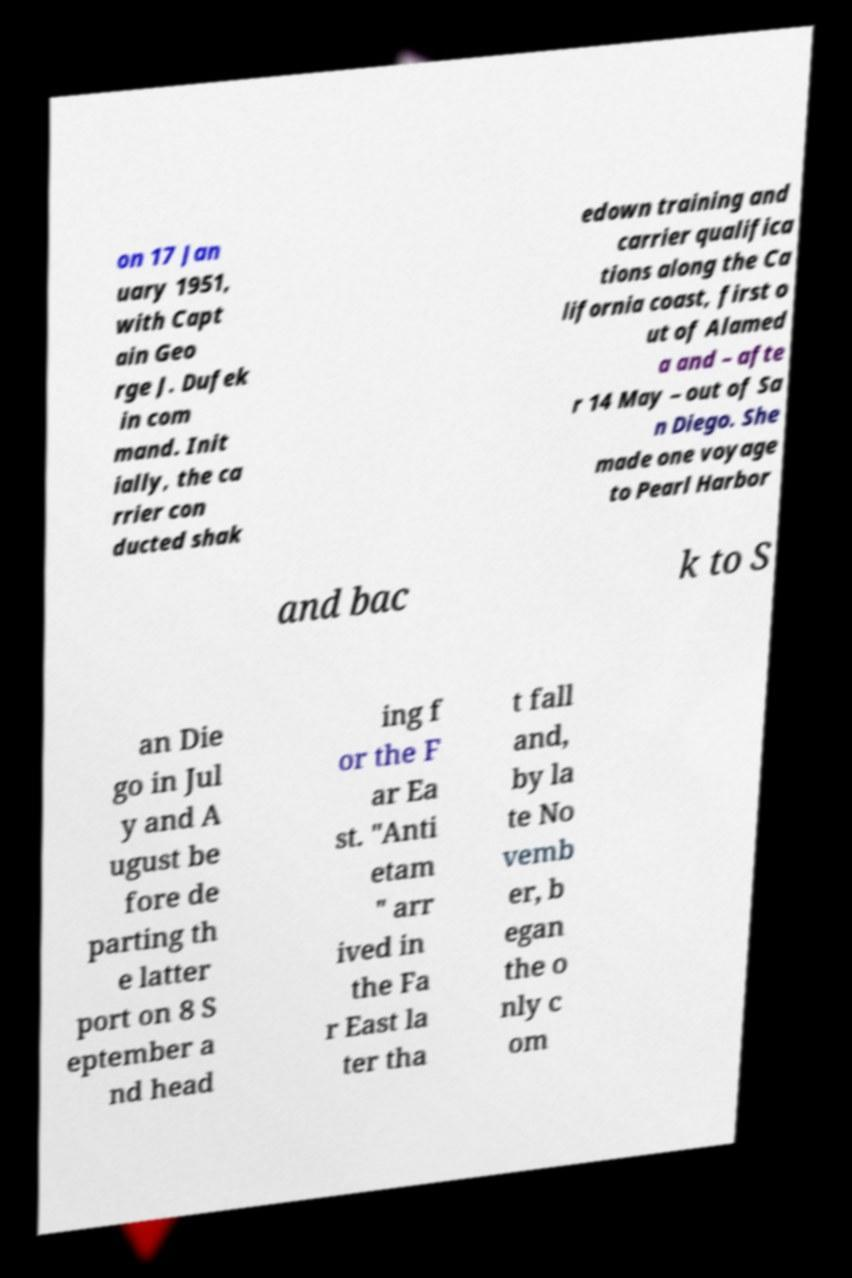For documentation purposes, I need the text within this image transcribed. Could you provide that? on 17 Jan uary 1951, with Capt ain Geo rge J. Dufek in com mand. Init ially, the ca rrier con ducted shak edown training and carrier qualifica tions along the Ca lifornia coast, first o ut of Alamed a and – afte r 14 May – out of Sa n Diego. She made one voyage to Pearl Harbor and bac k to S an Die go in Jul y and A ugust be fore de parting th e latter port on 8 S eptember a nd head ing f or the F ar Ea st. "Anti etam " arr ived in the Fa r East la ter tha t fall and, by la te No vemb er, b egan the o nly c om 